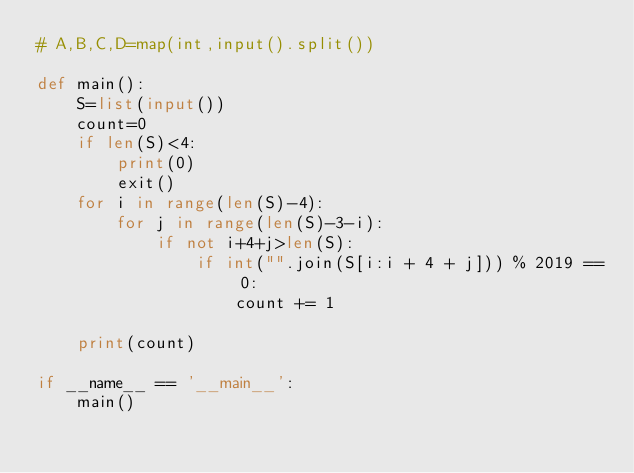Convert code to text. <code><loc_0><loc_0><loc_500><loc_500><_Python_># A,B,C,D=map(int,input().split())

def main():
    S=list(input())
    count=0
    if len(S)<4:
        print(0)
        exit()
    for i in range(len(S)-4):
        for j in range(len(S)-3-i):
            if not i+4+j>len(S):
                if int("".join(S[i:i + 4 + j])) % 2019 == 0:
                    count += 1

    print(count)

if __name__ == '__main__':
    main()</code> 